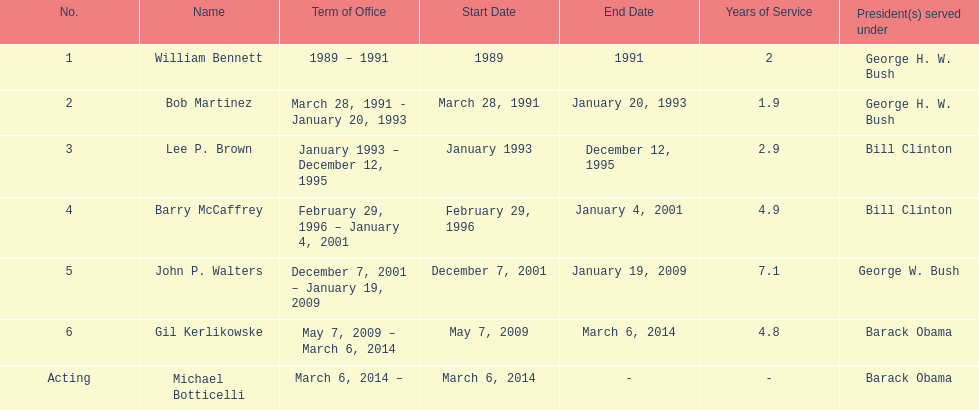How many directors served more than 3 years? 3. 